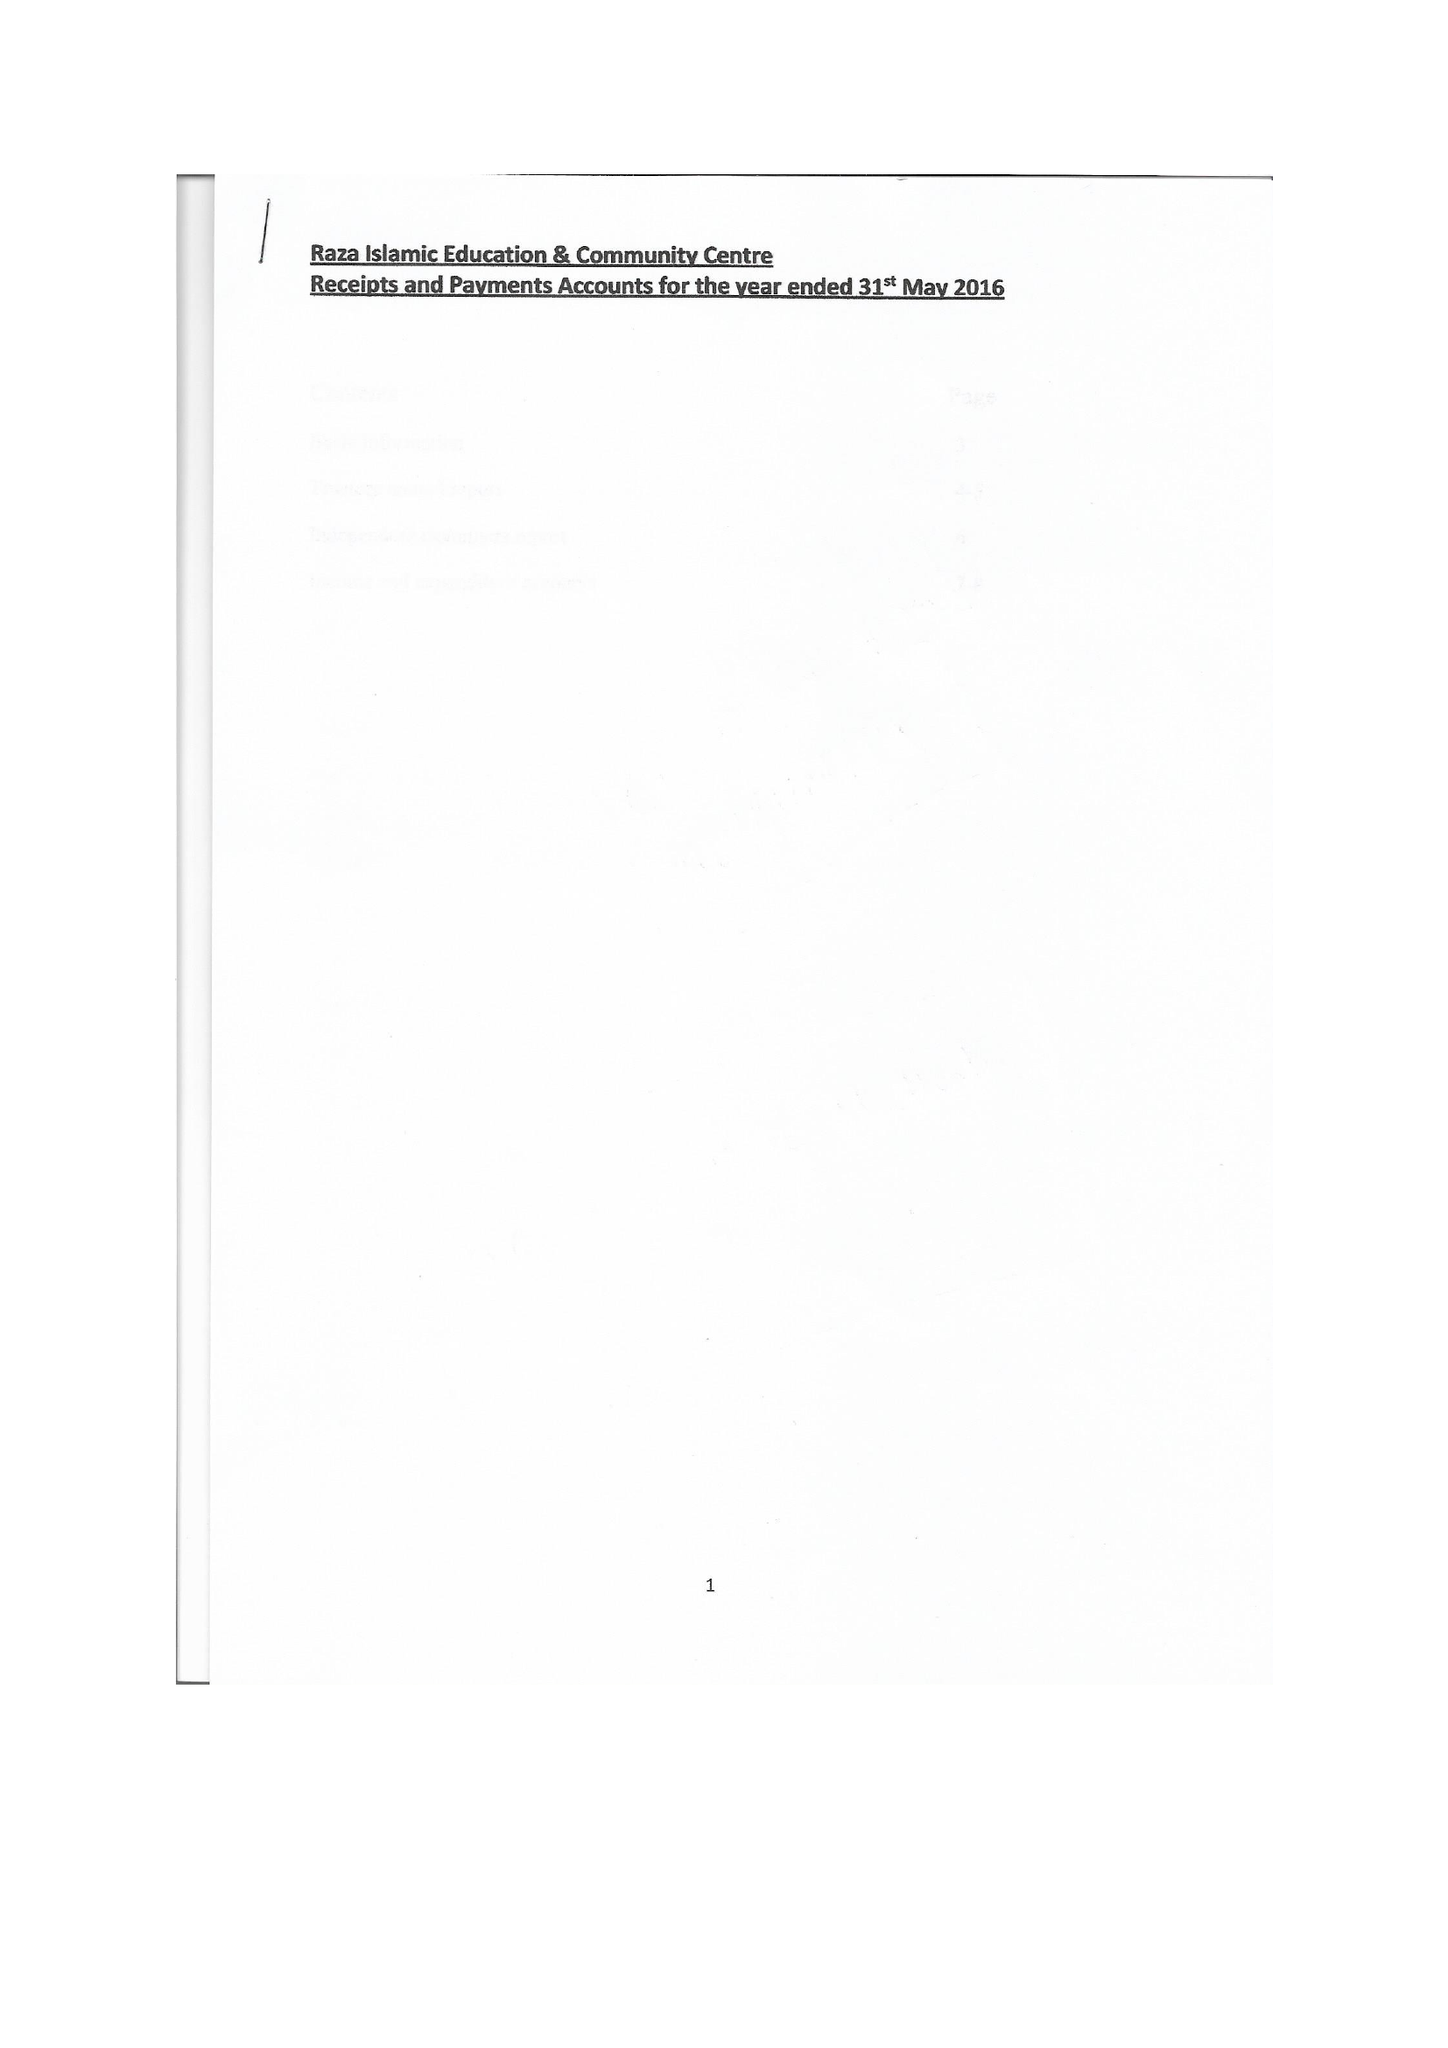What is the value for the charity_name?
Answer the question using a single word or phrase. Raza Islamic Education and Community Centre 